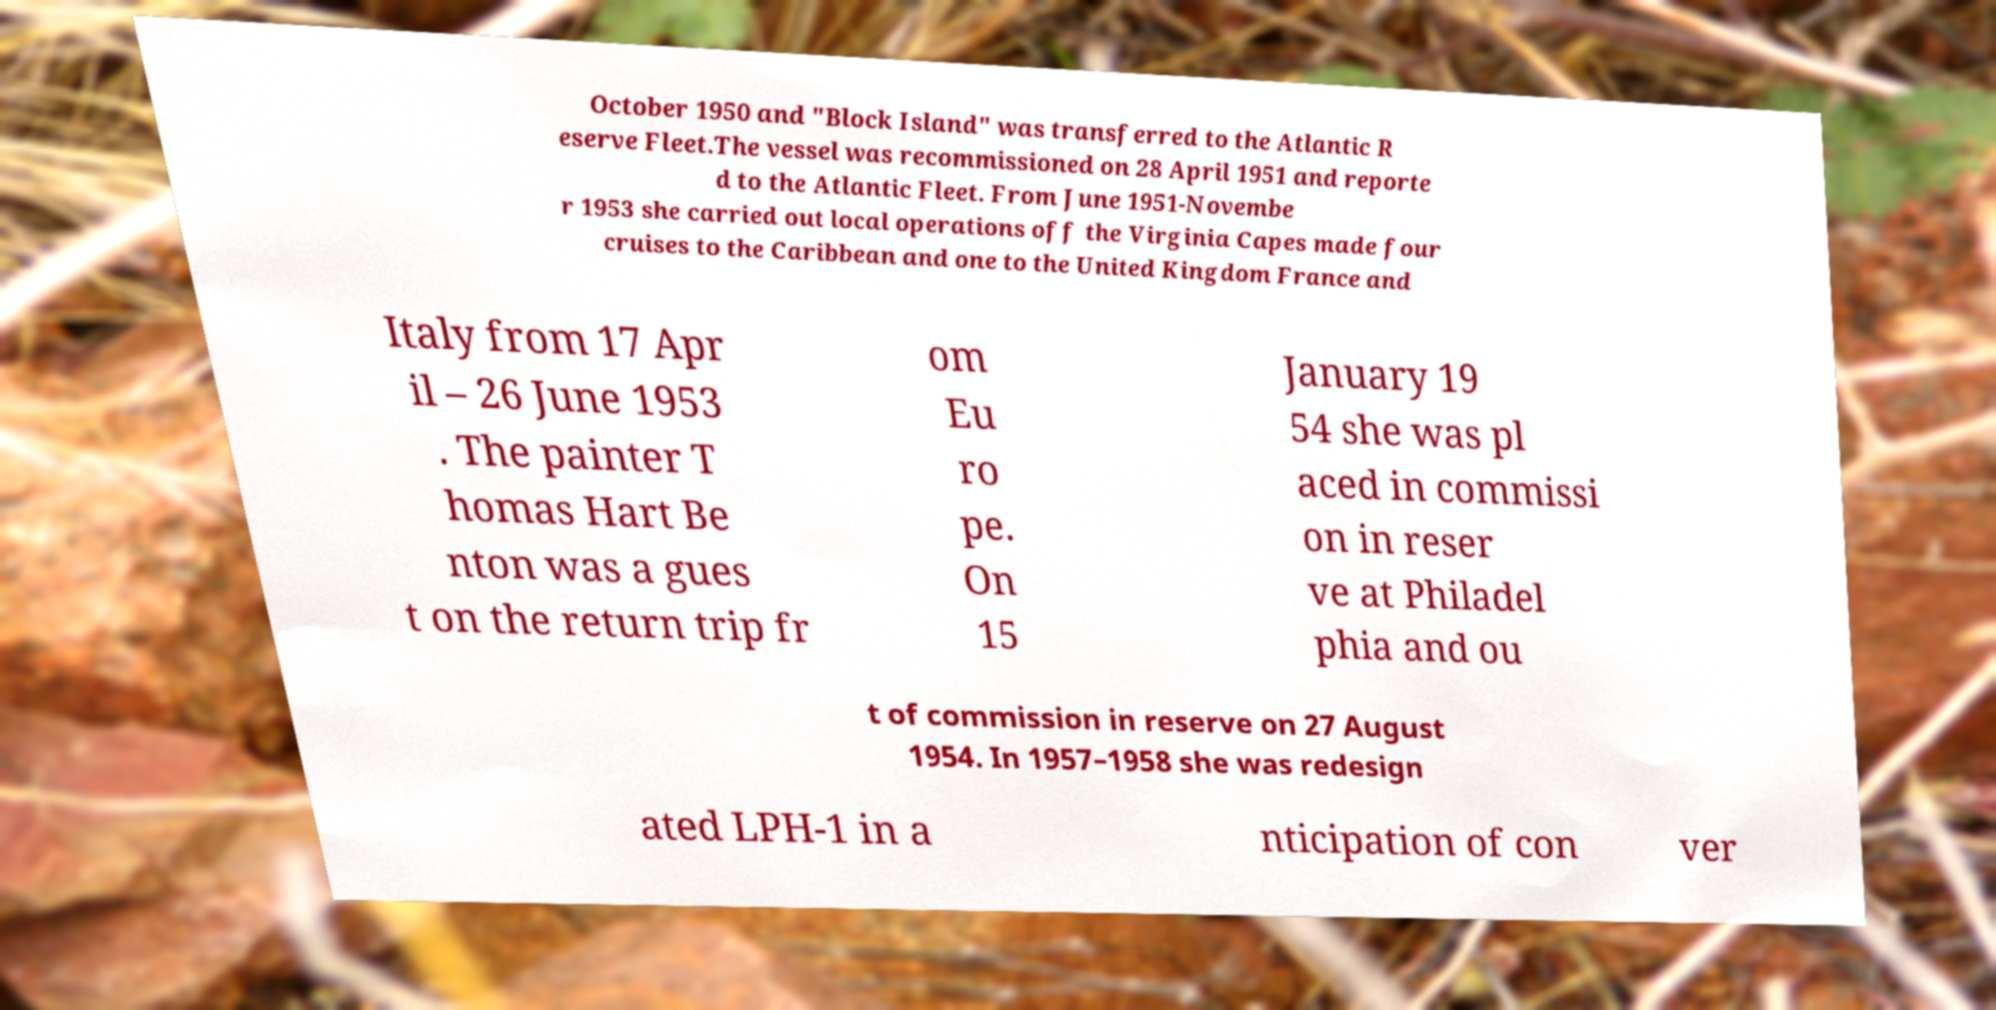Could you extract and type out the text from this image? October 1950 and "Block Island" was transferred to the Atlantic R eserve Fleet.The vessel was recommissioned on 28 April 1951 and reporte d to the Atlantic Fleet. From June 1951-Novembe r 1953 she carried out local operations off the Virginia Capes made four cruises to the Caribbean and one to the United Kingdom France and Italy from 17 Apr il – 26 June 1953 . The painter T homas Hart Be nton was a gues t on the return trip fr om Eu ro pe. On 15 January 19 54 she was pl aced in commissi on in reser ve at Philadel phia and ou t of commission in reserve on 27 August 1954. In 1957–1958 she was redesign ated LPH-1 in a nticipation of con ver 